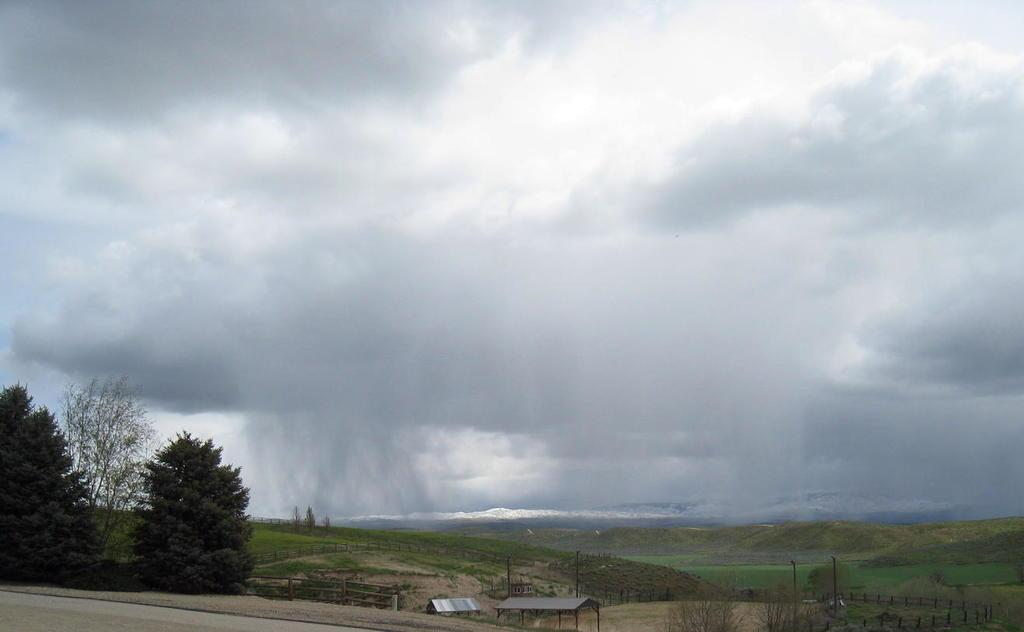What type of barrier can be seen in the image? There is a fence in the image. What type of vegetation is present in the image? There is grass and plants in the image. What type of landscape feature can be seen in the image? There are hills in the image. What is visible in the background of the image? The sky is visible in the background of the image. Can you hear the bead crying in the image? There is no bead or any indication of sound in the image. 